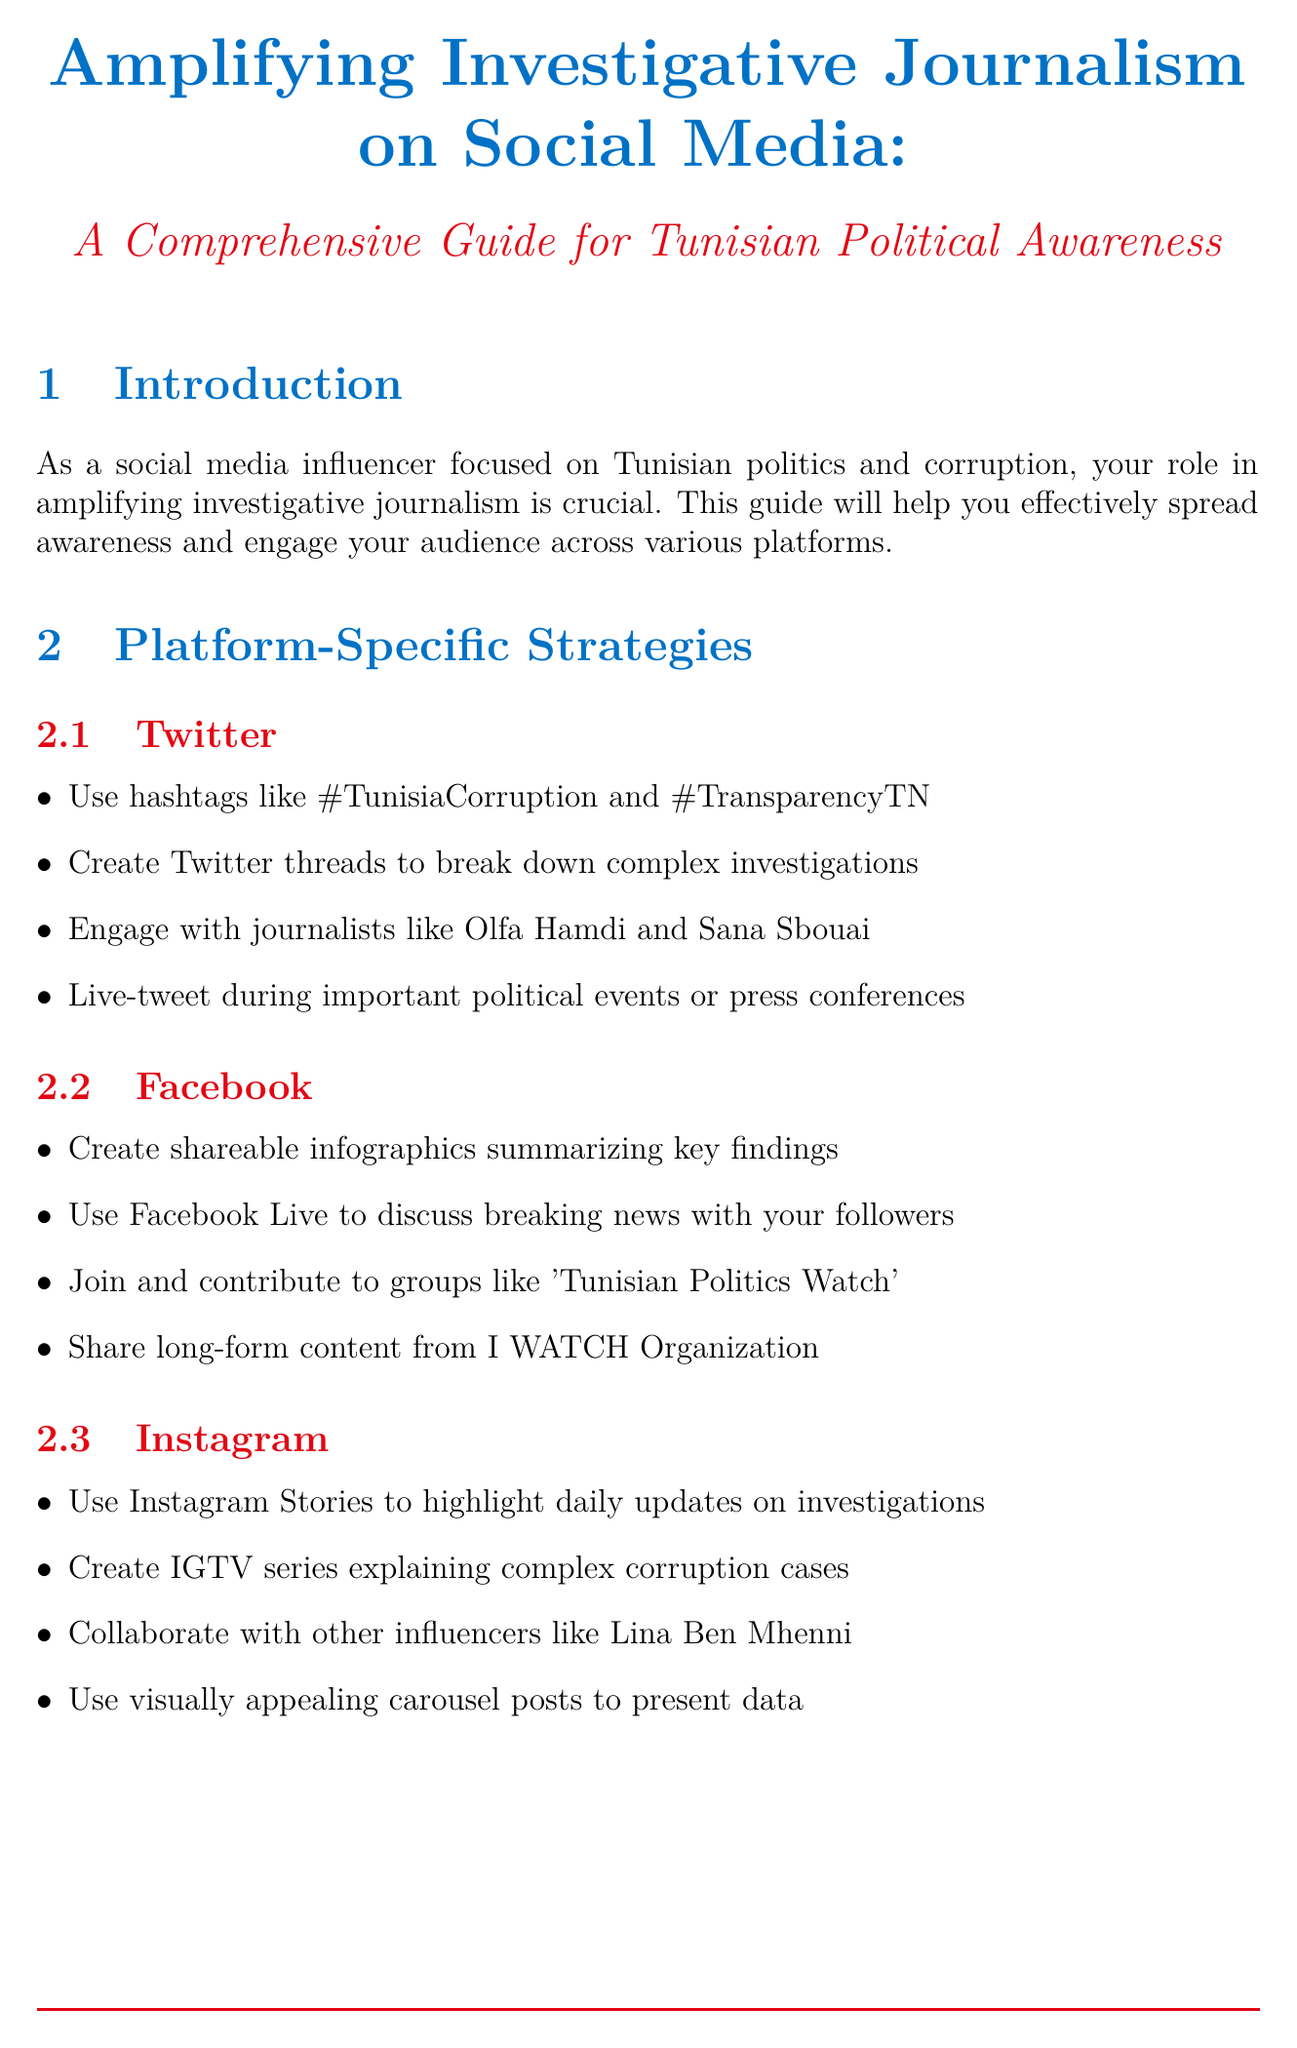What is the title of the document? The title provides the main subject of the guide on social media and investigative journalism in Tunisia.
Answer: Amplifying Investigative Journalism on Social Media: A Comprehensive Guide for Tunisian Political Awareness Which three social media platforms are covered in the platform-specific strategies? The guide details specific strategies for using various social media platforms to amplify investigative journalism.
Answer: Twitter, Facebook, Instagram What key tactic was used in the case study about Tunisian Customs? Each case study emphasizes distinct tactics used to address corruption issues through social media activism.
Answer: Created a viral hashtag #CustomsGate What is one engagement technique mentioned in the document? Engagement techniques are highlighted to interact with the audience effectively on social media.
Answer: Host Q&A sessions with investigative journalists How should the reach of content be measured? The document describes measuring various engagement metrics to assess the effectiveness of social media strategies.
Answer: Track the number of unique users who see your content Which organization is suggested for legal consultation? Legal considerations are important for influencers to ensure their activities comply with local laws.
Answer: Tunisian League for Human Rights What is a recommended content creation strategy? The guide suggests several strategies for creating impactful, anti-corruption content.
Answer: Summarize lengthy investigations into easily digestible bullet points What type of videos could be created to explain corruption cases on Instagram? The document outlines creative content formats suitable for educating audiences through social media.
Answer: IGTV series explaining complex corruption cases 